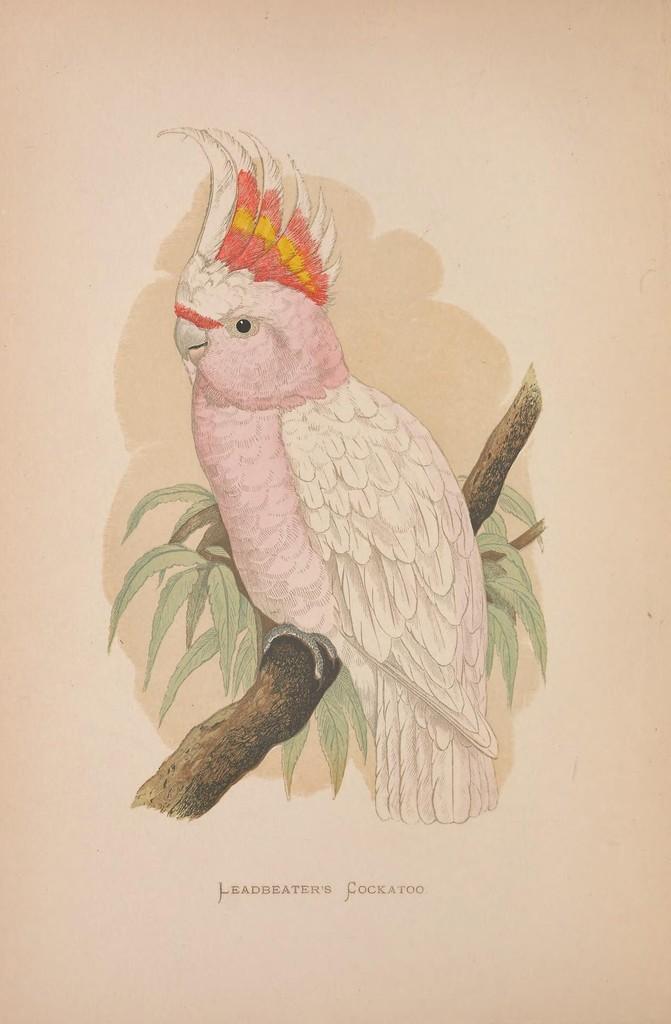In one or two sentences, can you explain what this image depicts? In this image I can see a painting of a bird which is on a stem. There are few leaves to the stem. At the bottom, I can see some text. The background is in white color. 